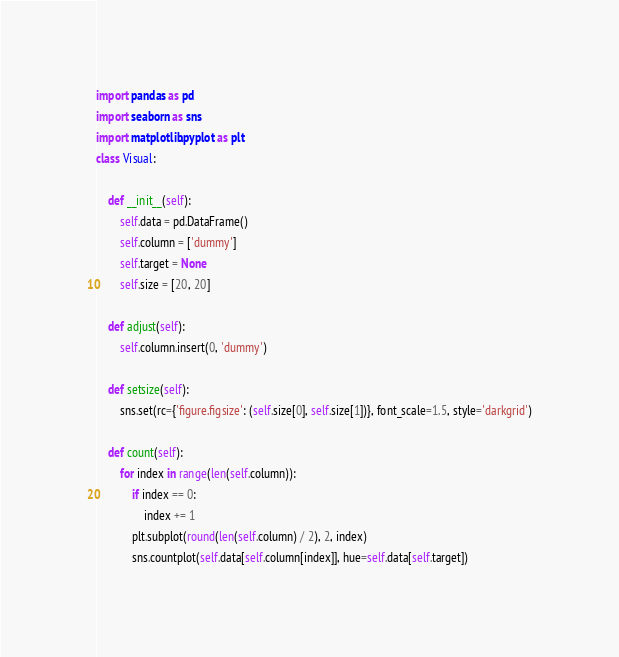<code> <loc_0><loc_0><loc_500><loc_500><_Python_>import pandas as pd
import seaborn as sns
import matplotlib.pyplot as plt
class Visual:

    def __init__(self):
        self.data = pd.DataFrame()
        self.column = ['dummy']
        self.target = None
        self.size = [20, 20]

    def adjust(self):
        self.column.insert(0, 'dummy')

    def setsize(self):
        sns.set(rc={'figure.figsize': (self.size[0], self.size[1])}, font_scale=1.5, style='darkgrid')

    def count(self):
        for index in range(len(self.column)):
            if index == 0:
                index += 1
            plt.subplot(round(len(self.column) / 2), 2, index)
            sns.countplot(self.data[self.column[index]], hue=self.data[self.target])

</code> 